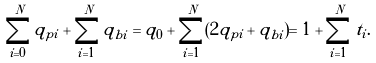<formula> <loc_0><loc_0><loc_500><loc_500>\sum _ { i = 0 } ^ { N } q _ { p i } + \sum _ { i = 1 } ^ { N } q _ { b i } = q _ { 0 } + \sum _ { i = 1 } ^ { N } ( 2 q _ { p i } + q _ { b i } ) = 1 + \sum _ { i = 1 } ^ { N } t _ { i } .</formula> 